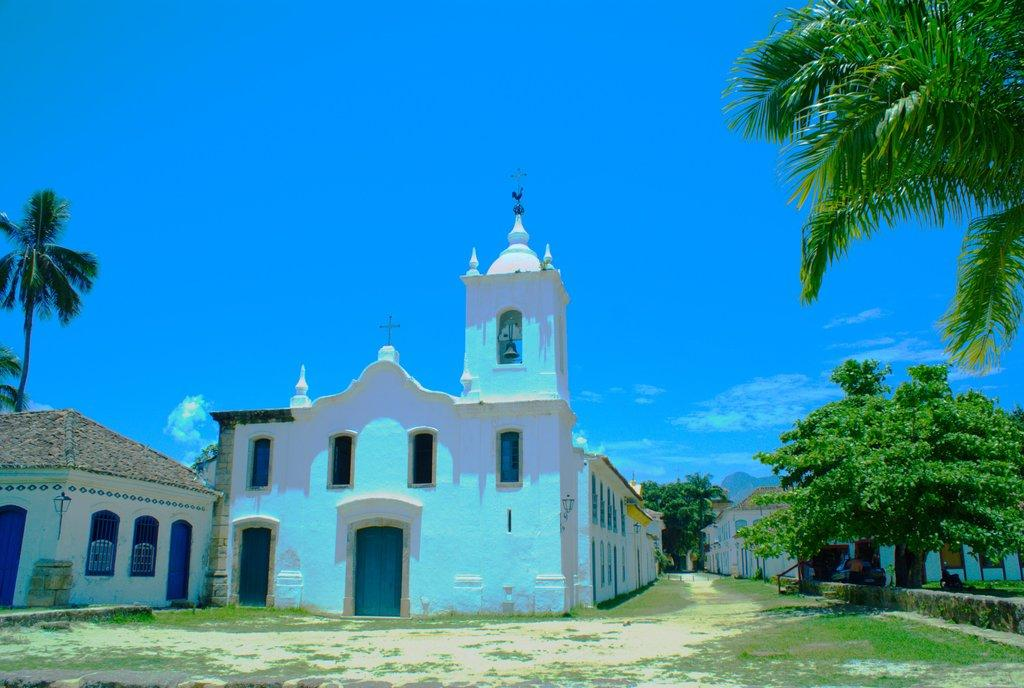What type of structures can be seen in the image? There are houses in the image. What type of vegetation is present in the image? There are trees and plants in the image. What type of ground cover is visible in the image? There is grass on the floor in the image. How many apples are hanging from the trees in the image? There are no apples present in the image; only trees and plants are visible. What type of base is supporting the houses in the image? The houses are not shown to be resting on any specific base in the image. 